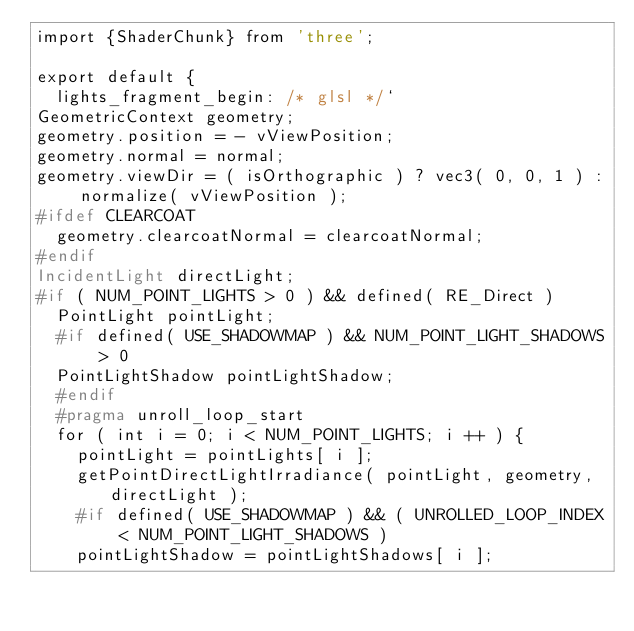Convert code to text. <code><loc_0><loc_0><loc_500><loc_500><_JavaScript_>import {ShaderChunk} from 'three';

export default {
	lights_fragment_begin: /* glsl */`
GeometricContext geometry;
geometry.position = - vViewPosition;
geometry.normal = normal;
geometry.viewDir = ( isOrthographic ) ? vec3( 0, 0, 1 ) : normalize( vViewPosition );
#ifdef CLEARCOAT
	geometry.clearcoatNormal = clearcoatNormal;
#endif
IncidentLight directLight;
#if ( NUM_POINT_LIGHTS > 0 ) && defined( RE_Direct )
	PointLight pointLight;
	#if defined( USE_SHADOWMAP ) && NUM_POINT_LIGHT_SHADOWS > 0
	PointLightShadow pointLightShadow;
	#endif
	#pragma unroll_loop_start
	for ( int i = 0; i < NUM_POINT_LIGHTS; i ++ ) {
		pointLight = pointLights[ i ];
		getPointDirectLightIrradiance( pointLight, geometry, directLight );
		#if defined( USE_SHADOWMAP ) && ( UNROLLED_LOOP_INDEX < NUM_POINT_LIGHT_SHADOWS )
		pointLightShadow = pointLightShadows[ i ];</code> 